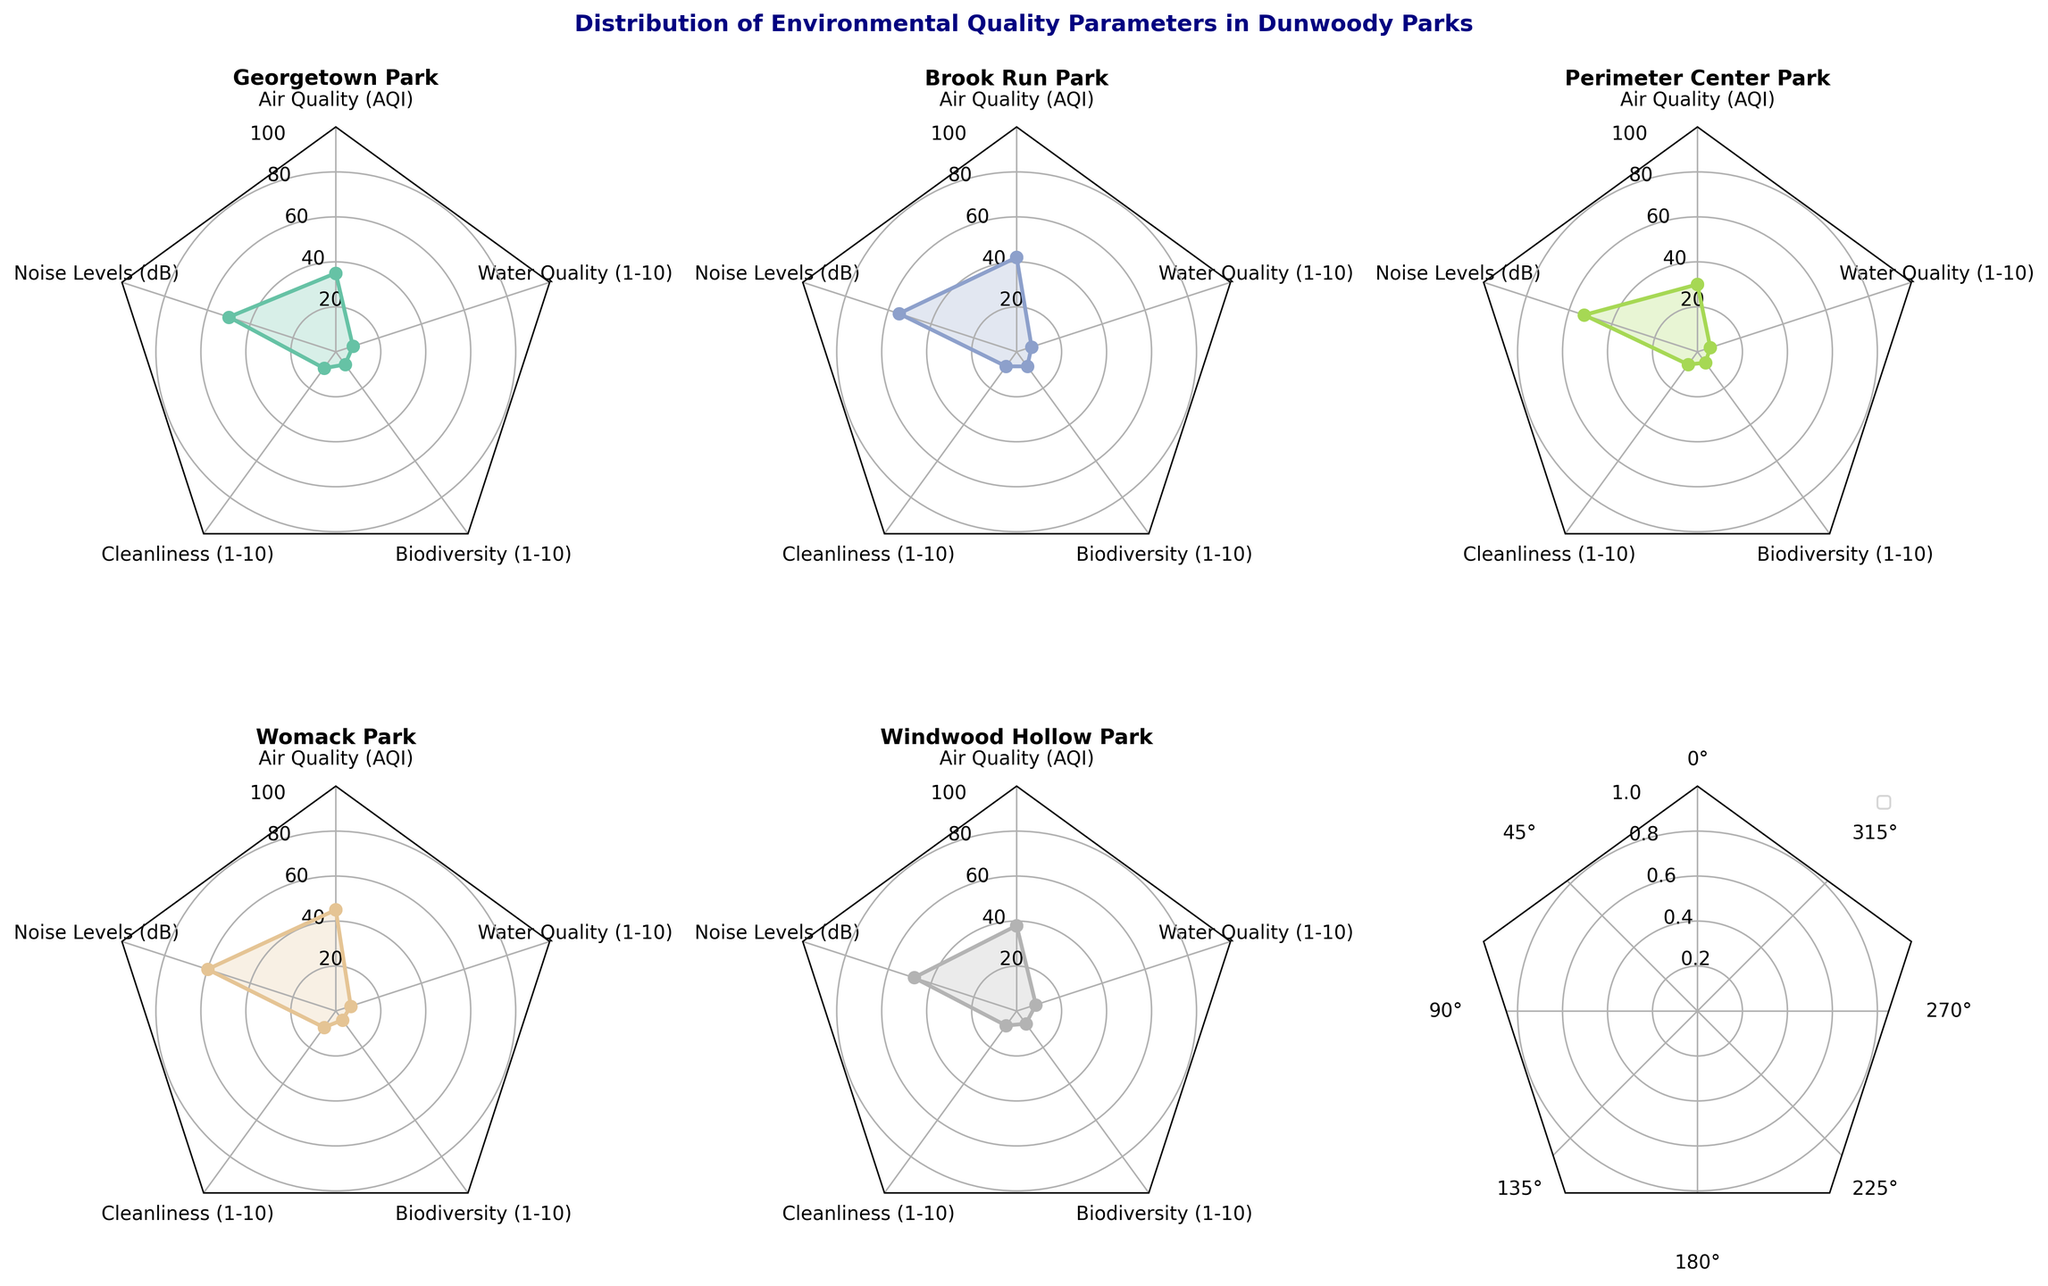Which park has the lowest Air Quality Index (AQI)? By examining the radar charts for each park, we can see that Perimeter Center Park has the lowest AQI at 30.
Answer: Perimeter Center Park What is the difference in Noise Levels (dB) between Womack Park and Windwood Hollow Park? Womack Park has a noise level of 60 dB, while Windwood Hollow Park has 48 dB. The difference is 60 - 48 = 12 dB.
Answer: 12 dB Which parks have identical Cleanliness ratings? According to the radar charts, Georgetown Park and Womack Park both have a Cleanliness rating of 9.
Answer: Georgetown Park and Womack Park Among all parks, which one has the highest rating for Biodiversity? By comparing the Biodiversity scores across the radar charts, Brook Run Park has the highest rating at 8.
Answer: Brook Run Park What is the average Water Quality rating across all parks? The Water Quality ratings are as follows: Georgetown Park (8), Brook Run Park (7), Perimeter Center Park (6), Womack Park (7), Windwood Hollow Park (9). The average is (8 + 7 + 6 + 7 + 9) / 5 = 37 / 5 = 7.4
Answer: 7.4 Which park shows the most balanced scores across all parameters? Brook Run Park has relatively consistent scores across all parameters without any extreme highs or lows.
Answer: Brook Run Park Is there any park that excels in both Cleanliness and Biodiversity simultaneously? The radar charts indicate that Brook Run Park has high scores in both Cleanliness (8) and Biodiversity (8).
Answer: Brook Run Park Which park has the lowest rating in any single parameter, and what is that parameter? According to the radar charts, Womack Park has the lowest Biodiversity rating at 5.
Answer: Womack Park, Biodiversity What are the notable differences between Georgetown Park and Windwood Hollow Park? Georgetown Park has better Air Quality (35 vs 38), higher Cleanliness (9 vs 8), but lower Biodiversity (7 vs 7) and Water Quality (8 vs 9) compared to Windwood Hollow Park.
Answer: Air Quality, Cleanliness, Biodiversity, Water Quality 